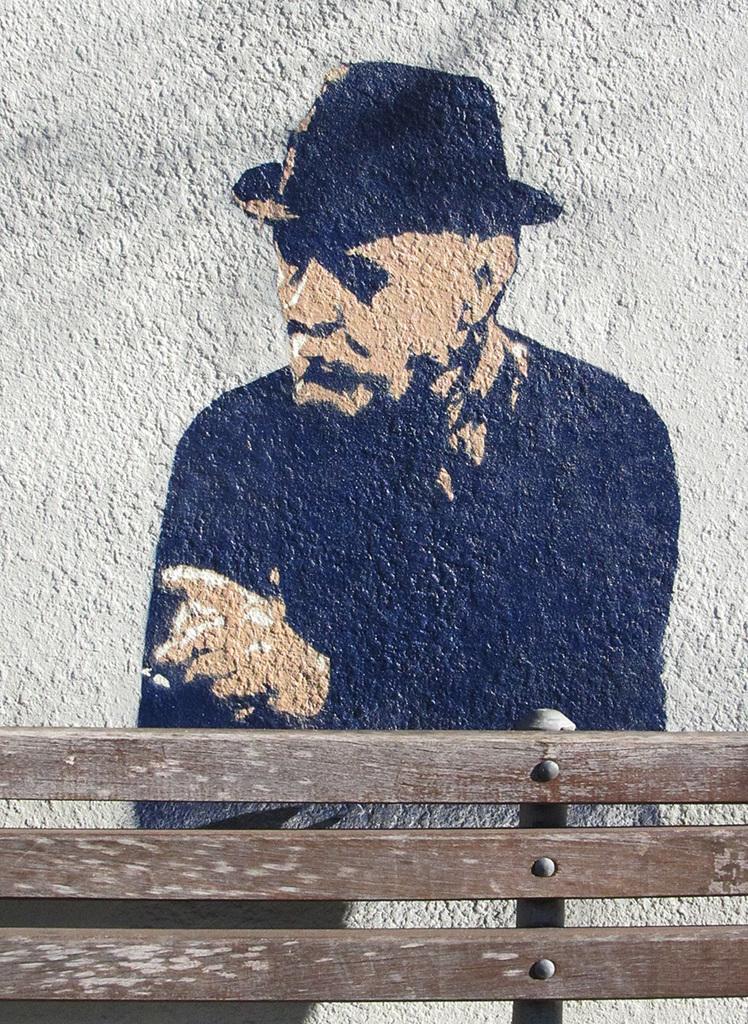Could you give a brief overview of what you see in this image? At the bottom of the picture, we see wooden sticks. It might be a wooden bench. Behind that, we see the painting of the man, which is drawn on the white wall. This might be a graffiti. 